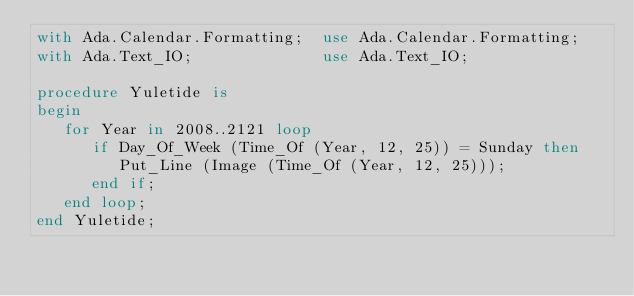<code> <loc_0><loc_0><loc_500><loc_500><_Ada_>with Ada.Calendar.Formatting;  use Ada.Calendar.Formatting;
with Ada.Text_IO;              use Ada.Text_IO;

procedure Yuletide is
begin
   for Year in 2008..2121 loop
      if Day_Of_Week (Time_Of (Year, 12, 25)) = Sunday then
         Put_Line (Image (Time_Of (Year, 12, 25)));
      end if;
   end loop;
end Yuletide;
</code> 